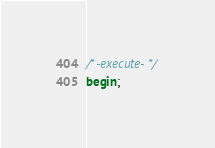<code> <loc_0><loc_0><loc_500><loc_500><_SQL_>/*-execute-*/
begin;</code> 